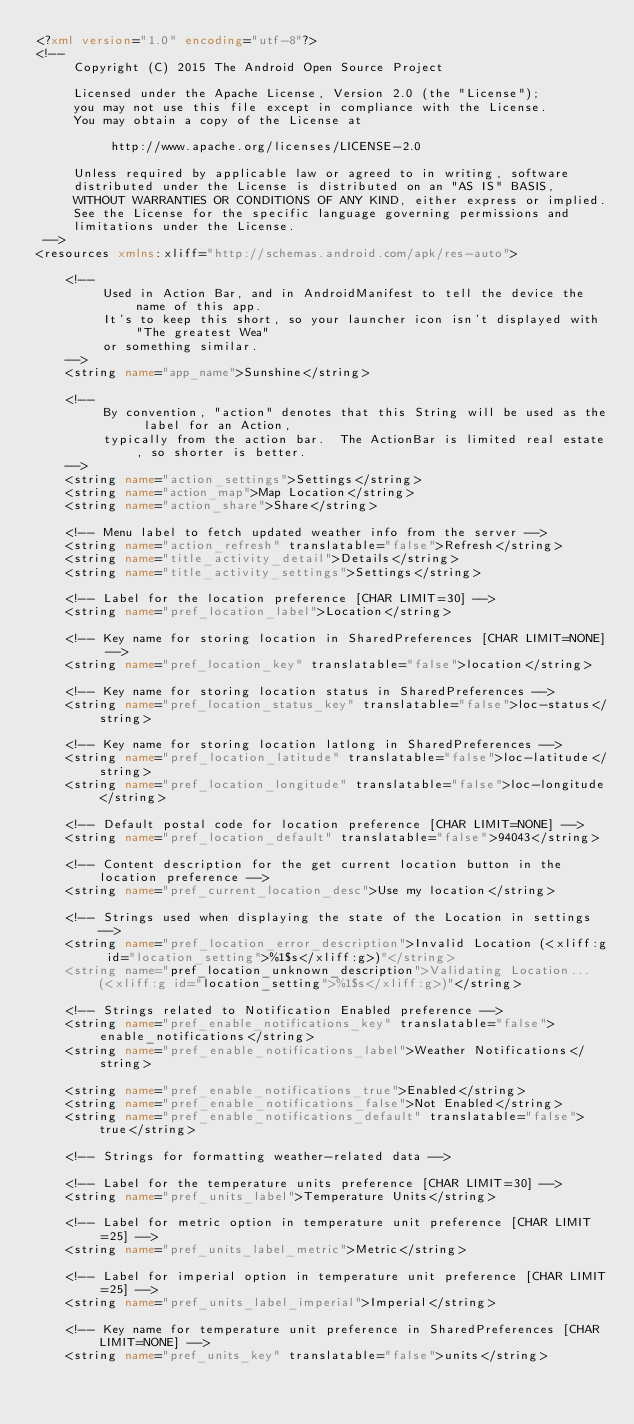<code> <loc_0><loc_0><loc_500><loc_500><_XML_><?xml version="1.0" encoding="utf-8"?>
<!--
     Copyright (C) 2015 The Android Open Source Project

     Licensed under the Apache License, Version 2.0 (the "License");
     you may not use this file except in compliance with the License.
     You may obtain a copy of the License at

          http://www.apache.org/licenses/LICENSE-2.0

     Unless required by applicable law or agreed to in writing, software
     distributed under the License is distributed on an "AS IS" BASIS,
     WITHOUT WARRANTIES OR CONDITIONS OF ANY KIND, either express or implied.
     See the License for the specific language governing permissions and
     limitations under the License.
 -->
<resources xmlns:xliff="http://schemas.android.com/apk/res-auto">

    <!--
         Used in Action Bar, and in AndroidManifest to tell the device the name of this app.
         It's to keep this short, so your launcher icon isn't displayed with "The greatest Wea"
         or something similar.
    -->
    <string name="app_name">Sunshine</string>

    <!--
         By convention, "action" denotes that this String will be used as the label for an Action,
         typically from the action bar.  The ActionBar is limited real estate, so shorter is better.
    -->
    <string name="action_settings">Settings</string>
    <string name="action_map">Map Location</string>
    <string name="action_share">Share</string>

    <!-- Menu label to fetch updated weather info from the server -->
    <string name="action_refresh" translatable="false">Refresh</string>
    <string name="title_activity_detail">Details</string>
    <string name="title_activity_settings">Settings</string>

    <!-- Label for the location preference [CHAR LIMIT=30] -->
    <string name="pref_location_label">Location</string>

    <!-- Key name for storing location in SharedPreferences [CHAR LIMIT=NONE] -->
    <string name="pref_location_key" translatable="false">location</string>

    <!-- Key name for storing location status in SharedPreferences -->
    <string name="pref_location_status_key" translatable="false">loc-status</string>

    <!-- Key name for storing location latlong in SharedPreferences -->
    <string name="pref_location_latitude" translatable="false">loc-latitude</string>
    <string name="pref_location_longitude" translatable="false">loc-longitude</string>

    <!-- Default postal code for location preference [CHAR LIMIT=NONE] -->
    <string name="pref_location_default" translatable="false">94043</string>

    <!-- Content description for the get current location button in the location preference -->
    <string name="pref_current_location_desc">Use my location</string>

    <!-- Strings used when displaying the state of the Location in settings -->
    <string name="pref_location_error_description">Invalid Location (<xliff:g id="location_setting">%1$s</xliff:g>)"</string>
    <string name="pref_location_unknown_description">Validating Location... (<xliff:g id="location_setting">%1$s</xliff:g>)"</string>

    <!-- Strings related to Notification Enabled preference -->
    <string name="pref_enable_notifications_key" translatable="false">enable_notifications</string>
    <string name="pref_enable_notifications_label">Weather Notifications</string>

    <string name="pref_enable_notifications_true">Enabled</string>
    <string name="pref_enable_notifications_false">Not Enabled</string>
    <string name="pref_enable_notifications_default" translatable="false">true</string>

    <!-- Strings for formatting weather-related data -->

    <!-- Label for the temperature units preference [CHAR LIMIT=30] -->
    <string name="pref_units_label">Temperature Units</string>

    <!-- Label for metric option in temperature unit preference [CHAR LIMIT=25] -->
    <string name="pref_units_label_metric">Metric</string>

    <!-- Label for imperial option in temperature unit preference [CHAR LIMIT=25] -->
    <string name="pref_units_label_imperial">Imperial</string>

    <!-- Key name for temperature unit preference in SharedPreferences [CHAR LIMIT=NONE] -->
    <string name="pref_units_key" translatable="false">units</string>
</code> 